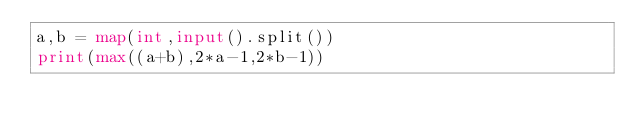<code> <loc_0><loc_0><loc_500><loc_500><_Python_>a,b = map(int,input().split())
print(max((a+b),2*a-1,2*b-1))</code> 